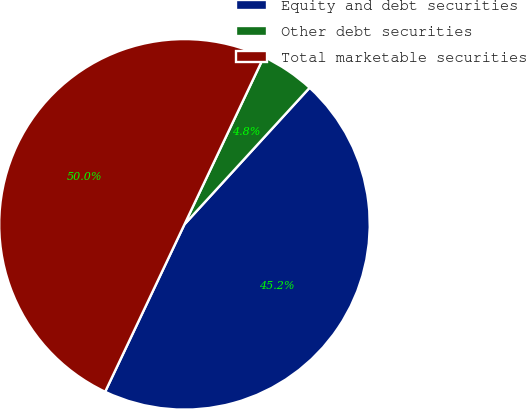Convert chart. <chart><loc_0><loc_0><loc_500><loc_500><pie_chart><fcel>Equity and debt securities<fcel>Other debt securities<fcel>Total marketable securities<nl><fcel>45.24%<fcel>4.76%<fcel>50.0%<nl></chart> 